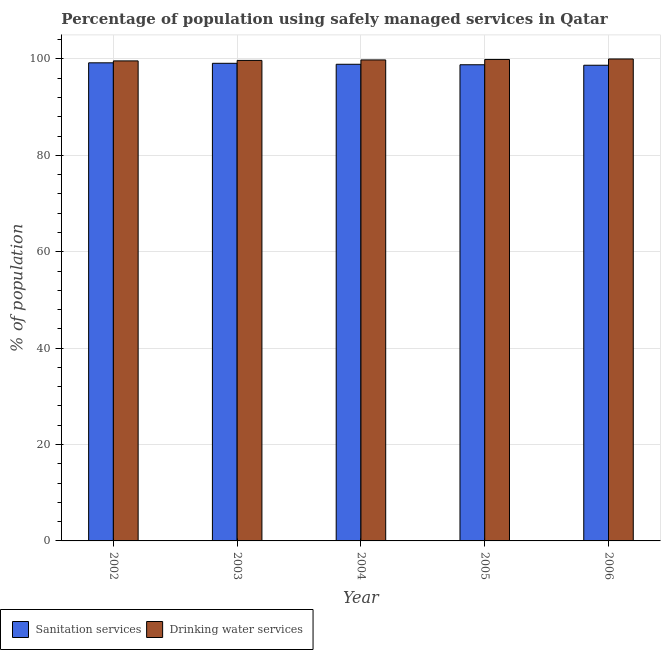How many different coloured bars are there?
Your answer should be very brief. 2. How many groups of bars are there?
Your answer should be compact. 5. Are the number of bars on each tick of the X-axis equal?
Provide a succinct answer. Yes. How many bars are there on the 5th tick from the left?
Offer a very short reply. 2. How many bars are there on the 1st tick from the right?
Your answer should be compact. 2. In how many cases, is the number of bars for a given year not equal to the number of legend labels?
Your response must be concise. 0. What is the percentage of population who used drinking water services in 2005?
Keep it short and to the point. 99.9. Across all years, what is the maximum percentage of population who used sanitation services?
Offer a very short reply. 99.2. Across all years, what is the minimum percentage of population who used drinking water services?
Keep it short and to the point. 99.6. In which year was the percentage of population who used sanitation services maximum?
Your response must be concise. 2002. What is the total percentage of population who used drinking water services in the graph?
Provide a succinct answer. 499. What is the difference between the percentage of population who used sanitation services in 2004 and that in 2005?
Keep it short and to the point. 0.1. What is the difference between the percentage of population who used sanitation services in 2006 and the percentage of population who used drinking water services in 2004?
Keep it short and to the point. -0.2. What is the average percentage of population who used sanitation services per year?
Keep it short and to the point. 98.94. In how many years, is the percentage of population who used drinking water services greater than 36 %?
Offer a terse response. 5. What is the ratio of the percentage of population who used sanitation services in 2002 to that in 2004?
Offer a terse response. 1. Is the difference between the percentage of population who used sanitation services in 2002 and 2004 greater than the difference between the percentage of population who used drinking water services in 2002 and 2004?
Your answer should be very brief. No. What is the difference between the highest and the second highest percentage of population who used sanitation services?
Your answer should be compact. 0.1. What is the difference between the highest and the lowest percentage of population who used drinking water services?
Ensure brevity in your answer.  0.4. In how many years, is the percentage of population who used sanitation services greater than the average percentage of population who used sanitation services taken over all years?
Ensure brevity in your answer.  2. Is the sum of the percentage of population who used drinking water services in 2003 and 2006 greater than the maximum percentage of population who used sanitation services across all years?
Offer a very short reply. Yes. What does the 1st bar from the left in 2003 represents?
Give a very brief answer. Sanitation services. What does the 1st bar from the right in 2005 represents?
Your response must be concise. Drinking water services. How many bars are there?
Your response must be concise. 10. Are all the bars in the graph horizontal?
Provide a short and direct response. No. How many years are there in the graph?
Your answer should be compact. 5. What is the difference between two consecutive major ticks on the Y-axis?
Your response must be concise. 20. Does the graph contain grids?
Give a very brief answer. Yes. Where does the legend appear in the graph?
Your response must be concise. Bottom left. How are the legend labels stacked?
Your answer should be very brief. Horizontal. What is the title of the graph?
Ensure brevity in your answer.  Percentage of population using safely managed services in Qatar. Does "Birth rate" appear as one of the legend labels in the graph?
Your response must be concise. No. What is the label or title of the X-axis?
Provide a short and direct response. Year. What is the label or title of the Y-axis?
Keep it short and to the point. % of population. What is the % of population in Sanitation services in 2002?
Offer a very short reply. 99.2. What is the % of population in Drinking water services in 2002?
Keep it short and to the point. 99.6. What is the % of population of Sanitation services in 2003?
Make the answer very short. 99.1. What is the % of population of Drinking water services in 2003?
Offer a very short reply. 99.7. What is the % of population of Sanitation services in 2004?
Provide a succinct answer. 98.9. What is the % of population of Drinking water services in 2004?
Make the answer very short. 99.8. What is the % of population of Sanitation services in 2005?
Your answer should be very brief. 98.8. What is the % of population in Drinking water services in 2005?
Offer a terse response. 99.9. What is the % of population of Sanitation services in 2006?
Ensure brevity in your answer.  98.7. What is the % of population in Drinking water services in 2006?
Offer a very short reply. 100. Across all years, what is the maximum % of population of Sanitation services?
Your response must be concise. 99.2. Across all years, what is the minimum % of population of Sanitation services?
Your answer should be very brief. 98.7. Across all years, what is the minimum % of population of Drinking water services?
Provide a succinct answer. 99.6. What is the total % of population in Sanitation services in the graph?
Your response must be concise. 494.7. What is the total % of population in Drinking water services in the graph?
Your response must be concise. 499. What is the difference between the % of population of Sanitation services in 2002 and that in 2003?
Make the answer very short. 0.1. What is the difference between the % of population of Sanitation services in 2002 and that in 2005?
Your answer should be very brief. 0.4. What is the difference between the % of population of Drinking water services in 2002 and that in 2005?
Make the answer very short. -0.3. What is the difference between the % of population of Drinking water services in 2003 and that in 2004?
Give a very brief answer. -0.1. What is the difference between the % of population of Sanitation services in 2003 and that in 2005?
Provide a succinct answer. 0.3. What is the difference between the % of population of Drinking water services in 2003 and that in 2005?
Give a very brief answer. -0.2. What is the difference between the % of population of Sanitation services in 2003 and that in 2006?
Your answer should be very brief. 0.4. What is the difference between the % of population in Drinking water services in 2003 and that in 2006?
Offer a very short reply. -0.3. What is the difference between the % of population of Sanitation services in 2004 and that in 2005?
Your answer should be very brief. 0.1. What is the difference between the % of population of Sanitation services in 2004 and that in 2006?
Your answer should be very brief. 0.2. What is the difference between the % of population of Sanitation services in 2005 and that in 2006?
Provide a short and direct response. 0.1. What is the difference between the % of population in Sanitation services in 2002 and the % of population in Drinking water services in 2003?
Give a very brief answer. -0.5. What is the difference between the % of population of Sanitation services in 2002 and the % of population of Drinking water services in 2004?
Provide a succinct answer. -0.6. What is the difference between the % of population of Sanitation services in 2002 and the % of population of Drinking water services in 2006?
Offer a very short reply. -0.8. What is the difference between the % of population in Sanitation services in 2004 and the % of population in Drinking water services in 2005?
Provide a short and direct response. -1. What is the difference between the % of population in Sanitation services in 2004 and the % of population in Drinking water services in 2006?
Your answer should be very brief. -1.1. What is the difference between the % of population of Sanitation services in 2005 and the % of population of Drinking water services in 2006?
Ensure brevity in your answer.  -1.2. What is the average % of population in Sanitation services per year?
Offer a very short reply. 98.94. What is the average % of population of Drinking water services per year?
Keep it short and to the point. 99.8. In the year 2003, what is the difference between the % of population of Sanitation services and % of population of Drinking water services?
Your answer should be compact. -0.6. In the year 2005, what is the difference between the % of population in Sanitation services and % of population in Drinking water services?
Offer a very short reply. -1.1. In the year 2006, what is the difference between the % of population in Sanitation services and % of population in Drinking water services?
Provide a short and direct response. -1.3. What is the ratio of the % of population of Drinking water services in 2002 to that in 2003?
Give a very brief answer. 1. What is the ratio of the % of population of Drinking water services in 2002 to that in 2004?
Your answer should be very brief. 1. What is the ratio of the % of population of Sanitation services in 2002 to that in 2005?
Provide a succinct answer. 1. What is the ratio of the % of population in Drinking water services in 2002 to that in 2005?
Make the answer very short. 1. What is the ratio of the % of population in Sanitation services in 2002 to that in 2006?
Ensure brevity in your answer.  1.01. What is the ratio of the % of population in Sanitation services in 2003 to that in 2004?
Keep it short and to the point. 1. What is the ratio of the % of population of Sanitation services in 2003 to that in 2005?
Your answer should be very brief. 1. What is the ratio of the % of population in Drinking water services in 2003 to that in 2005?
Make the answer very short. 1. What is the ratio of the % of population of Sanitation services in 2004 to that in 2005?
Keep it short and to the point. 1. What is the ratio of the % of population in Drinking water services in 2004 to that in 2005?
Make the answer very short. 1. What is the ratio of the % of population in Sanitation services in 2004 to that in 2006?
Give a very brief answer. 1. What is the difference between the highest and the second highest % of population in Sanitation services?
Give a very brief answer. 0.1. What is the difference between the highest and the second highest % of population of Drinking water services?
Give a very brief answer. 0.1. What is the difference between the highest and the lowest % of population of Drinking water services?
Provide a succinct answer. 0.4. 